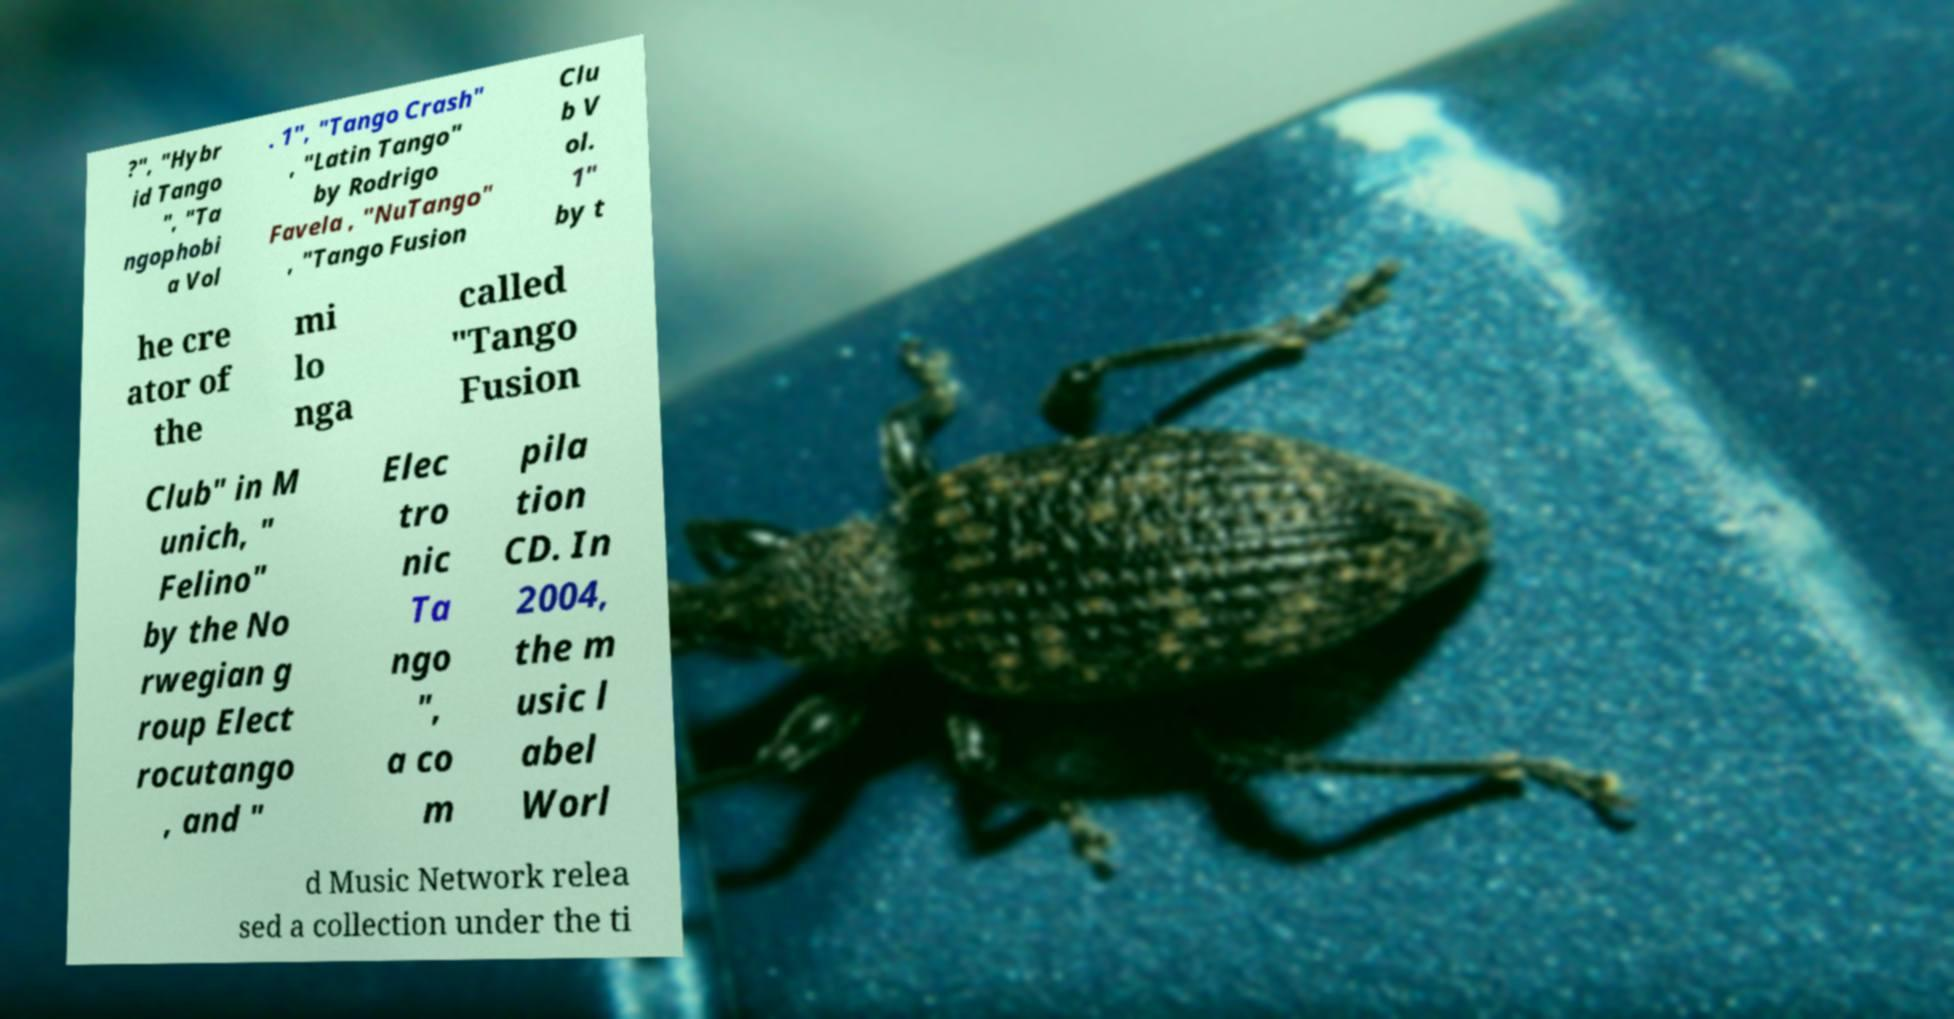Could you extract and type out the text from this image? ?", "Hybr id Tango ", "Ta ngophobi a Vol . 1", "Tango Crash" , "Latin Tango" by Rodrigo Favela , "NuTango" , "Tango Fusion Clu b V ol. 1" by t he cre ator of the mi lo nga called "Tango Fusion Club" in M unich, " Felino" by the No rwegian g roup Elect rocutango , and " Elec tro nic Ta ngo ", a co m pila tion CD. In 2004, the m usic l abel Worl d Music Network relea sed a collection under the ti 